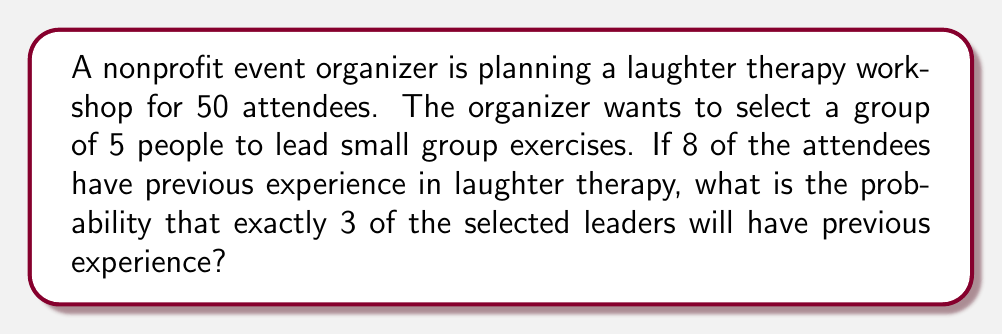Teach me how to tackle this problem. Let's approach this step-by-step:

1) We need to use the hypergeometric distribution, as we are selecting without replacement from a finite population.

2) Let's define our variables:
   $N = 50$ (total attendees)
   $K = 8$ (attendees with experience)
   $n = 5$ (leaders to be selected)
   $k = 3$ (leaders we want to have experience)

3) The probability is given by the formula:

   $$P(X = k) = \frac{\binom{K}{k} \binom{N-K}{n-k}}{\binom{N}{n}}$$

4) Let's calculate each combination:

   $\binom{K}{k} = \binom{8}{3} = 56$
   $\binom{N-K}{n-k} = \binom{42}{2} = 861$
   $\binom{N}{n} = \binom{50}{5} = 2,118,760$

5) Now, let's substitute these values into our formula:

   $$P(X = 3) = \frac{56 \times 861}{2,118,760} = \frac{48,216}{2,118,760}$$

6) Simplifying this fraction:

   $$P(X = 3) = \frac{6,027}{264,845} \approx 0.0228$$

7) Therefore, the probability is approximately 0.0228 or 2.28%.
Answer: $\frac{6,027}{264,845}$ or approximately 0.0228 